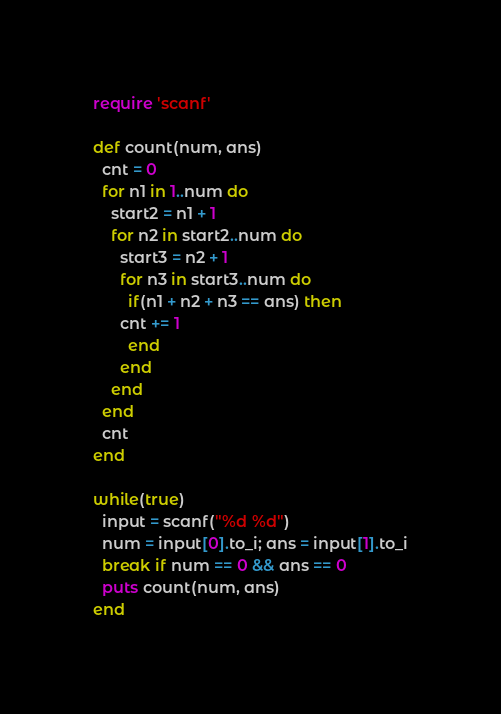<code> <loc_0><loc_0><loc_500><loc_500><_Ruby_>require 'scanf'

def count(num, ans)
  cnt = 0
  for n1 in 1..num do
    start2 = n1 + 1
    for n2 in start2..num do
      start3 = n2 + 1
      for n3 in start3..num do
        if(n1 + n2 + n3 == ans) then
	  cnt += 1
        end
      end
    end
  end
  cnt
end

while(true)
  input = scanf("%d %d")
  num = input[0].to_i; ans = input[1].to_i
  break if num == 0 && ans == 0
  puts count(num, ans)
end</code> 